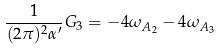Convert formula to latex. <formula><loc_0><loc_0><loc_500><loc_500>\frac { 1 } { ( 2 \pi ) ^ { 2 } \alpha ^ { \prime } } G _ { 3 } = - 4 \omega _ { A _ { 2 } } - 4 \omega _ { A _ { 3 } }</formula> 